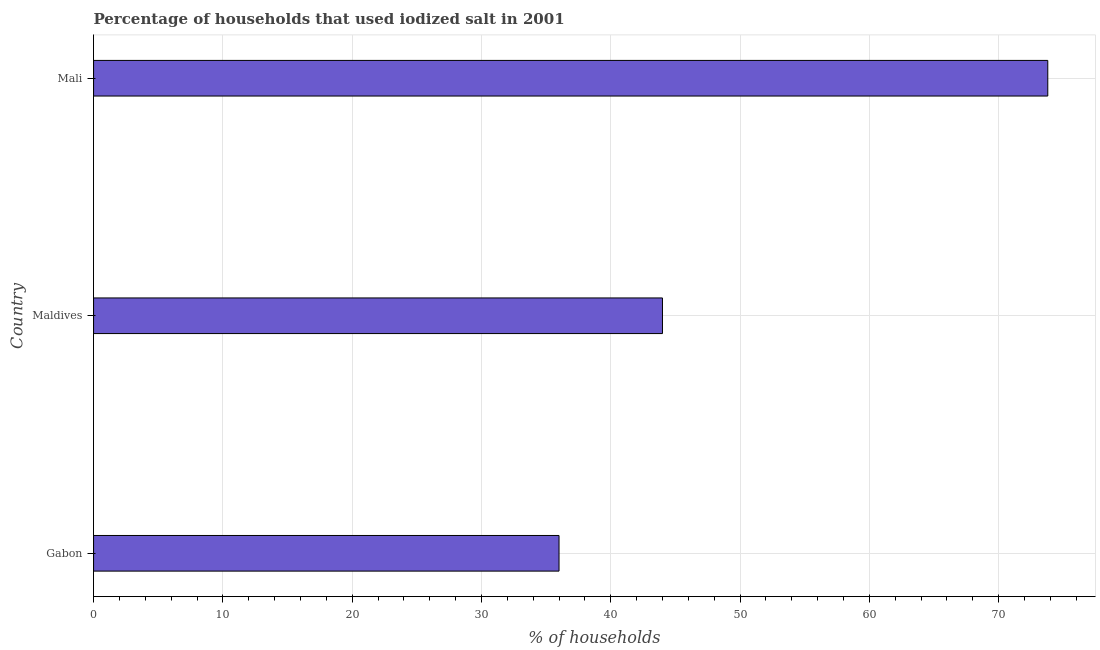Does the graph contain any zero values?
Your answer should be compact. No. Does the graph contain grids?
Ensure brevity in your answer.  Yes. What is the title of the graph?
Make the answer very short. Percentage of households that used iodized salt in 2001. What is the label or title of the X-axis?
Give a very brief answer. % of households. What is the label or title of the Y-axis?
Make the answer very short. Country. What is the percentage of households where iodized salt is consumed in Mali?
Provide a succinct answer. 73.8. Across all countries, what is the maximum percentage of households where iodized salt is consumed?
Offer a terse response. 73.8. In which country was the percentage of households where iodized salt is consumed maximum?
Keep it short and to the point. Mali. In which country was the percentage of households where iodized salt is consumed minimum?
Offer a terse response. Gabon. What is the sum of the percentage of households where iodized salt is consumed?
Offer a very short reply. 153.8. What is the difference between the percentage of households where iodized salt is consumed in Maldives and Mali?
Your answer should be very brief. -29.8. What is the average percentage of households where iodized salt is consumed per country?
Your answer should be compact. 51.27. What is the ratio of the percentage of households where iodized salt is consumed in Maldives to that in Mali?
Your answer should be very brief. 0.6. What is the difference between the highest and the second highest percentage of households where iodized salt is consumed?
Give a very brief answer. 29.8. Is the sum of the percentage of households where iodized salt is consumed in Gabon and Mali greater than the maximum percentage of households where iodized salt is consumed across all countries?
Make the answer very short. Yes. What is the difference between the highest and the lowest percentage of households where iodized salt is consumed?
Give a very brief answer. 37.8. What is the difference between two consecutive major ticks on the X-axis?
Provide a short and direct response. 10. What is the % of households in Mali?
Make the answer very short. 73.8. What is the difference between the % of households in Gabon and Maldives?
Offer a terse response. -8. What is the difference between the % of households in Gabon and Mali?
Give a very brief answer. -37.8. What is the difference between the % of households in Maldives and Mali?
Ensure brevity in your answer.  -29.8. What is the ratio of the % of households in Gabon to that in Maldives?
Provide a succinct answer. 0.82. What is the ratio of the % of households in Gabon to that in Mali?
Keep it short and to the point. 0.49. What is the ratio of the % of households in Maldives to that in Mali?
Ensure brevity in your answer.  0.6. 